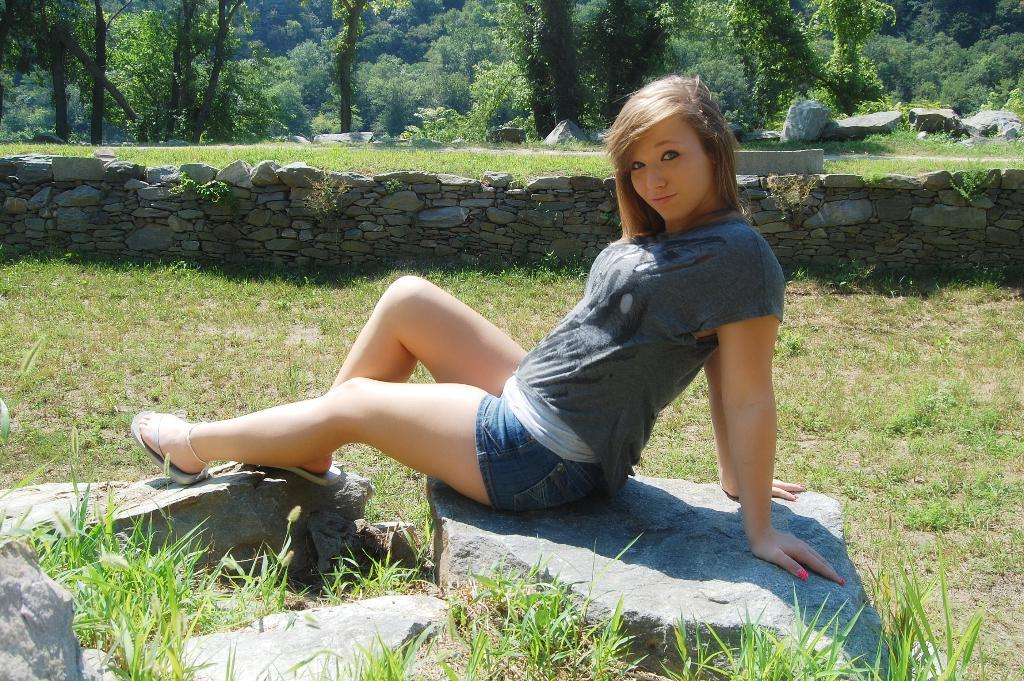What is the person in the image doing? The person is sitting in the image. What type of surface is visible beneath the person? The ground is visible in the image. What type of vegetation can be seen in the image? There is grass, plants, and trees in the image. What other objects or materials are present in the image? There are stones and a wall in the image. What type of development is the rabbit undergoing in the image? There is no rabbit present in the image, so it is not possible to discuss any development related to a rabbit. 